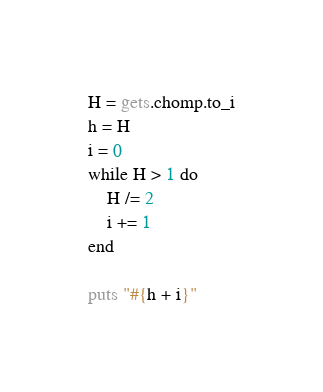<code> <loc_0><loc_0><loc_500><loc_500><_Ruby_>H = gets.chomp.to_i
h = H
i = 0
while H > 1 do
    H /= 2
    i += 1  
end

puts "#{h + i}"</code> 